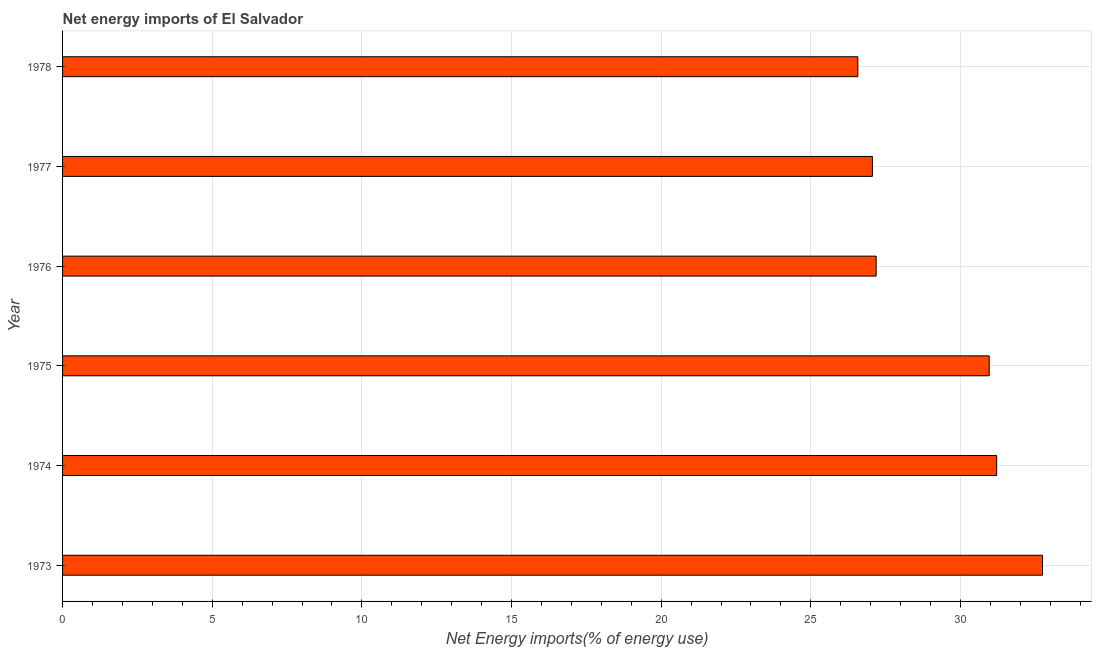Does the graph contain any zero values?
Provide a succinct answer. No. What is the title of the graph?
Ensure brevity in your answer.  Net energy imports of El Salvador. What is the label or title of the X-axis?
Your response must be concise. Net Energy imports(% of energy use). What is the energy imports in 1973?
Give a very brief answer. 32.74. Across all years, what is the maximum energy imports?
Your answer should be compact. 32.74. Across all years, what is the minimum energy imports?
Offer a very short reply. 26.57. In which year was the energy imports maximum?
Your response must be concise. 1973. In which year was the energy imports minimum?
Your response must be concise. 1978. What is the sum of the energy imports?
Your answer should be compact. 175.72. What is the difference between the energy imports in 1974 and 1975?
Ensure brevity in your answer.  0.25. What is the average energy imports per year?
Provide a short and direct response. 29.29. What is the median energy imports?
Provide a short and direct response. 29.07. In how many years, is the energy imports greater than 28 %?
Your answer should be very brief. 3. What is the ratio of the energy imports in 1973 to that in 1977?
Give a very brief answer. 1.21. Is the difference between the energy imports in 1975 and 1978 greater than the difference between any two years?
Keep it short and to the point. No. What is the difference between the highest and the second highest energy imports?
Your answer should be very brief. 1.53. What is the difference between the highest and the lowest energy imports?
Make the answer very short. 6.17. In how many years, is the energy imports greater than the average energy imports taken over all years?
Provide a succinct answer. 3. How many bars are there?
Ensure brevity in your answer.  6. Are all the bars in the graph horizontal?
Your response must be concise. Yes. How many years are there in the graph?
Ensure brevity in your answer.  6. What is the Net Energy imports(% of energy use) of 1973?
Provide a succinct answer. 32.74. What is the Net Energy imports(% of energy use) in 1974?
Make the answer very short. 31.21. What is the Net Energy imports(% of energy use) in 1975?
Ensure brevity in your answer.  30.96. What is the Net Energy imports(% of energy use) of 1976?
Offer a terse response. 27.18. What is the Net Energy imports(% of energy use) of 1977?
Make the answer very short. 27.06. What is the Net Energy imports(% of energy use) in 1978?
Make the answer very short. 26.57. What is the difference between the Net Energy imports(% of energy use) in 1973 and 1974?
Offer a terse response. 1.53. What is the difference between the Net Energy imports(% of energy use) in 1973 and 1975?
Offer a very short reply. 1.78. What is the difference between the Net Energy imports(% of energy use) in 1973 and 1976?
Your answer should be very brief. 5.56. What is the difference between the Net Energy imports(% of energy use) in 1973 and 1977?
Provide a short and direct response. 5.68. What is the difference between the Net Energy imports(% of energy use) in 1973 and 1978?
Offer a very short reply. 6.17. What is the difference between the Net Energy imports(% of energy use) in 1974 and 1975?
Offer a terse response. 0.25. What is the difference between the Net Energy imports(% of energy use) in 1974 and 1976?
Offer a very short reply. 4.03. What is the difference between the Net Energy imports(% of energy use) in 1974 and 1977?
Your answer should be very brief. 4.15. What is the difference between the Net Energy imports(% of energy use) in 1974 and 1978?
Provide a succinct answer. 4.64. What is the difference between the Net Energy imports(% of energy use) in 1975 and 1976?
Your response must be concise. 3.78. What is the difference between the Net Energy imports(% of energy use) in 1975 and 1977?
Give a very brief answer. 3.9. What is the difference between the Net Energy imports(% of energy use) in 1975 and 1978?
Ensure brevity in your answer.  4.39. What is the difference between the Net Energy imports(% of energy use) in 1976 and 1977?
Your answer should be compact. 0.13. What is the difference between the Net Energy imports(% of energy use) in 1976 and 1978?
Your answer should be compact. 0.61. What is the difference between the Net Energy imports(% of energy use) in 1977 and 1978?
Offer a very short reply. 0.49. What is the ratio of the Net Energy imports(% of energy use) in 1973 to that in 1974?
Offer a very short reply. 1.05. What is the ratio of the Net Energy imports(% of energy use) in 1973 to that in 1975?
Provide a succinct answer. 1.06. What is the ratio of the Net Energy imports(% of energy use) in 1973 to that in 1976?
Provide a succinct answer. 1.2. What is the ratio of the Net Energy imports(% of energy use) in 1973 to that in 1977?
Make the answer very short. 1.21. What is the ratio of the Net Energy imports(% of energy use) in 1973 to that in 1978?
Keep it short and to the point. 1.23. What is the ratio of the Net Energy imports(% of energy use) in 1974 to that in 1975?
Your answer should be very brief. 1.01. What is the ratio of the Net Energy imports(% of energy use) in 1974 to that in 1976?
Make the answer very short. 1.15. What is the ratio of the Net Energy imports(% of energy use) in 1974 to that in 1977?
Your response must be concise. 1.15. What is the ratio of the Net Energy imports(% of energy use) in 1974 to that in 1978?
Provide a short and direct response. 1.18. What is the ratio of the Net Energy imports(% of energy use) in 1975 to that in 1976?
Your answer should be very brief. 1.14. What is the ratio of the Net Energy imports(% of energy use) in 1975 to that in 1977?
Offer a terse response. 1.14. What is the ratio of the Net Energy imports(% of energy use) in 1975 to that in 1978?
Offer a very short reply. 1.17. What is the ratio of the Net Energy imports(% of energy use) in 1976 to that in 1978?
Your answer should be compact. 1.02. 